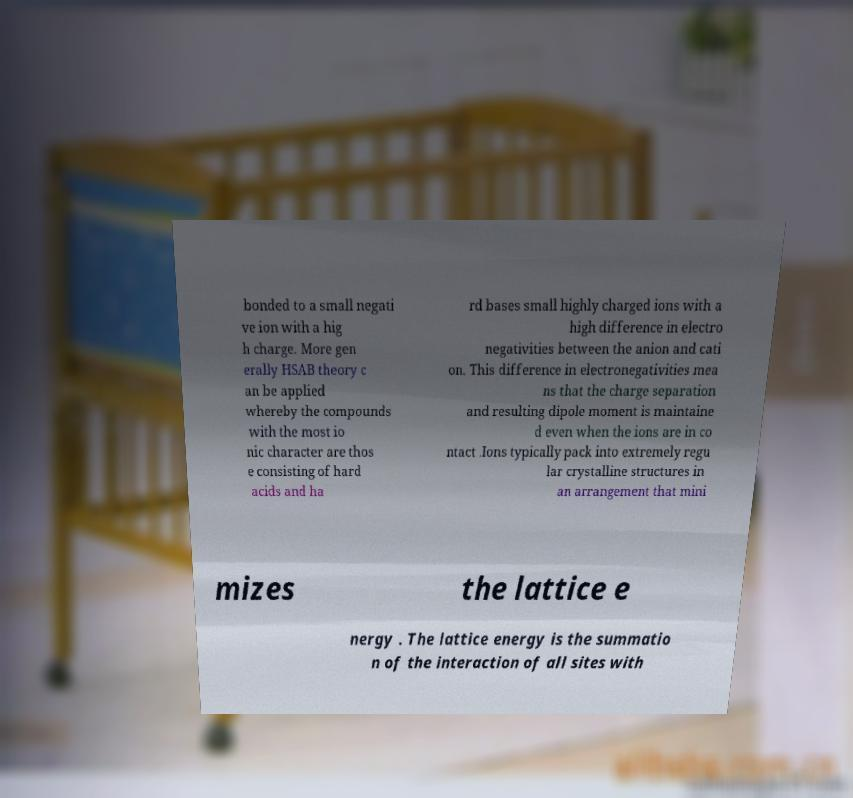What messages or text are displayed in this image? I need them in a readable, typed format. bonded to a small negati ve ion with a hig h charge. More gen erally HSAB theory c an be applied whereby the compounds with the most io nic character are thos e consisting of hard acids and ha rd bases small highly charged ions with a high difference in electro negativities between the anion and cati on. This difference in electronegativities mea ns that the charge separation and resulting dipole moment is maintaine d even when the ions are in co ntact .Ions typically pack into extremely regu lar crystalline structures in an arrangement that mini mizes the lattice e nergy . The lattice energy is the summatio n of the interaction of all sites with 